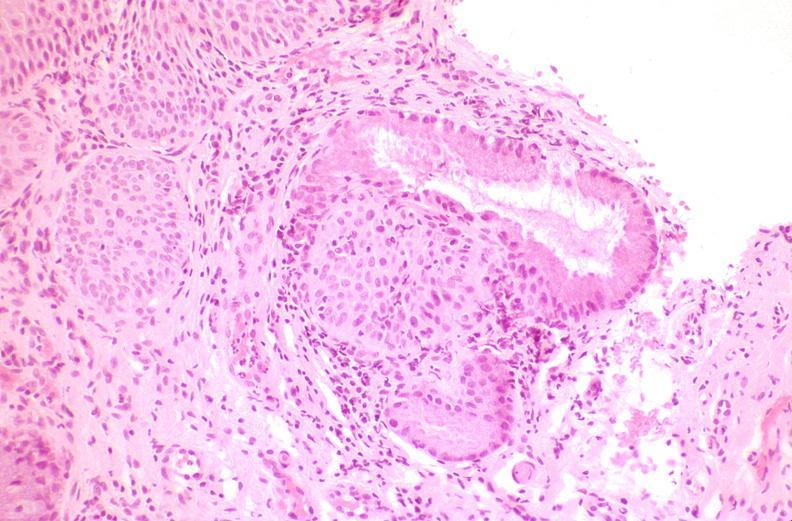does edema show cervix, squamous metaplasia?
Answer the question using a single word or phrase. No 